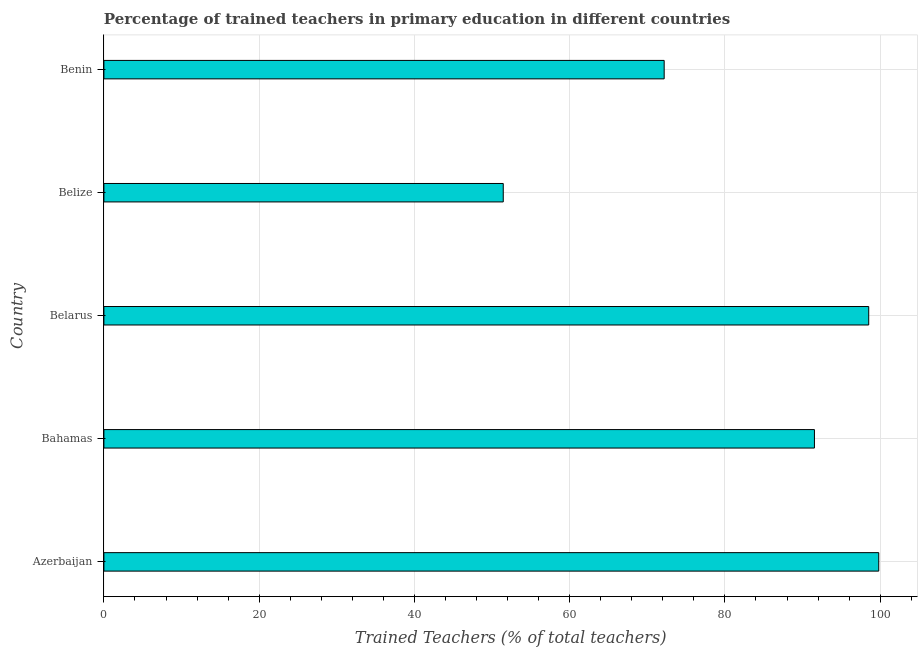What is the title of the graph?
Keep it short and to the point. Percentage of trained teachers in primary education in different countries. What is the label or title of the X-axis?
Your answer should be very brief. Trained Teachers (% of total teachers). What is the label or title of the Y-axis?
Offer a very short reply. Country. What is the percentage of trained teachers in Bahamas?
Provide a short and direct response. 91.53. Across all countries, what is the maximum percentage of trained teachers?
Keep it short and to the point. 99.82. Across all countries, what is the minimum percentage of trained teachers?
Make the answer very short. 51.45. In which country was the percentage of trained teachers maximum?
Offer a terse response. Azerbaijan. In which country was the percentage of trained teachers minimum?
Provide a succinct answer. Belize. What is the sum of the percentage of trained teachers?
Offer a terse response. 413.5. What is the difference between the percentage of trained teachers in Azerbaijan and Belarus?
Your response must be concise. 1.29. What is the average percentage of trained teachers per country?
Give a very brief answer. 82.7. What is the median percentage of trained teachers?
Offer a very short reply. 91.53. What is the ratio of the percentage of trained teachers in Bahamas to that in Belize?
Your answer should be compact. 1.78. Is the percentage of trained teachers in Azerbaijan less than that in Belarus?
Your answer should be compact. No. Is the difference between the percentage of trained teachers in Azerbaijan and Belize greater than the difference between any two countries?
Keep it short and to the point. Yes. What is the difference between the highest and the second highest percentage of trained teachers?
Offer a very short reply. 1.29. What is the difference between the highest and the lowest percentage of trained teachers?
Make the answer very short. 48.37. How many bars are there?
Your response must be concise. 5. Are all the bars in the graph horizontal?
Offer a very short reply. Yes. How many countries are there in the graph?
Keep it short and to the point. 5. What is the difference between two consecutive major ticks on the X-axis?
Your answer should be very brief. 20. Are the values on the major ticks of X-axis written in scientific E-notation?
Your answer should be compact. No. What is the Trained Teachers (% of total teachers) in Azerbaijan?
Offer a very short reply. 99.82. What is the Trained Teachers (% of total teachers) of Bahamas?
Keep it short and to the point. 91.53. What is the Trained Teachers (% of total teachers) in Belarus?
Offer a terse response. 98.53. What is the Trained Teachers (% of total teachers) of Belize?
Keep it short and to the point. 51.45. What is the Trained Teachers (% of total teachers) in Benin?
Offer a very short reply. 72.18. What is the difference between the Trained Teachers (% of total teachers) in Azerbaijan and Bahamas?
Your answer should be very brief. 8.28. What is the difference between the Trained Teachers (% of total teachers) in Azerbaijan and Belarus?
Provide a succinct answer. 1.29. What is the difference between the Trained Teachers (% of total teachers) in Azerbaijan and Belize?
Make the answer very short. 48.37. What is the difference between the Trained Teachers (% of total teachers) in Azerbaijan and Benin?
Provide a succinct answer. 27.64. What is the difference between the Trained Teachers (% of total teachers) in Bahamas and Belarus?
Offer a terse response. -6.99. What is the difference between the Trained Teachers (% of total teachers) in Bahamas and Belize?
Offer a terse response. 40.09. What is the difference between the Trained Teachers (% of total teachers) in Bahamas and Benin?
Make the answer very short. 19.36. What is the difference between the Trained Teachers (% of total teachers) in Belarus and Belize?
Provide a succinct answer. 47.08. What is the difference between the Trained Teachers (% of total teachers) in Belarus and Benin?
Offer a terse response. 26.35. What is the difference between the Trained Teachers (% of total teachers) in Belize and Benin?
Provide a short and direct response. -20.73. What is the ratio of the Trained Teachers (% of total teachers) in Azerbaijan to that in Bahamas?
Your response must be concise. 1.09. What is the ratio of the Trained Teachers (% of total teachers) in Azerbaijan to that in Belarus?
Ensure brevity in your answer.  1.01. What is the ratio of the Trained Teachers (% of total teachers) in Azerbaijan to that in Belize?
Your answer should be compact. 1.94. What is the ratio of the Trained Teachers (% of total teachers) in Azerbaijan to that in Benin?
Offer a terse response. 1.38. What is the ratio of the Trained Teachers (% of total teachers) in Bahamas to that in Belarus?
Ensure brevity in your answer.  0.93. What is the ratio of the Trained Teachers (% of total teachers) in Bahamas to that in Belize?
Give a very brief answer. 1.78. What is the ratio of the Trained Teachers (% of total teachers) in Bahamas to that in Benin?
Provide a short and direct response. 1.27. What is the ratio of the Trained Teachers (% of total teachers) in Belarus to that in Belize?
Provide a short and direct response. 1.92. What is the ratio of the Trained Teachers (% of total teachers) in Belarus to that in Benin?
Ensure brevity in your answer.  1.36. What is the ratio of the Trained Teachers (% of total teachers) in Belize to that in Benin?
Provide a succinct answer. 0.71. 